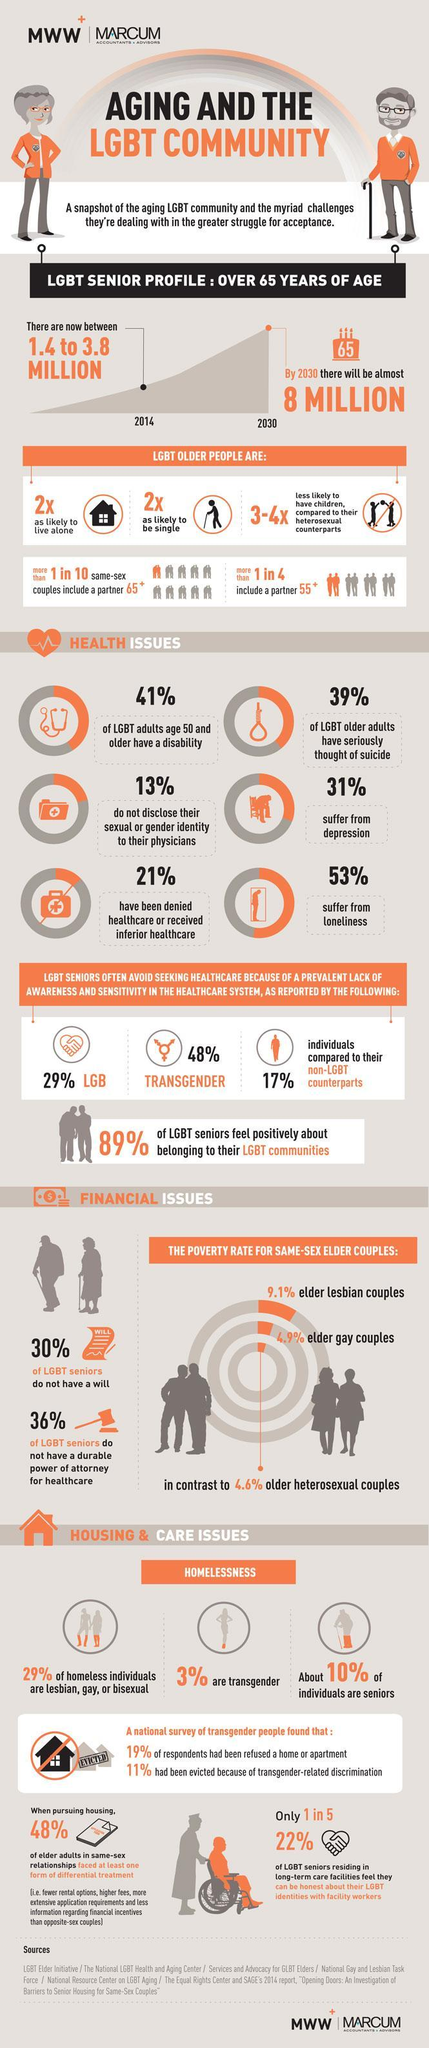how many suffer from depression
Answer the question with a short phrase. 31% what percent of LGBT seniors have a will 70 how many suffer from loneliness 53% what will be the LGBT senior populaiton by 2030 8 million what is the LGBT senior population in 2014 1.4 to 3.8 million how higher is the poverty rate of elder lesbian couples compared to older heterosexual couples 4.5 